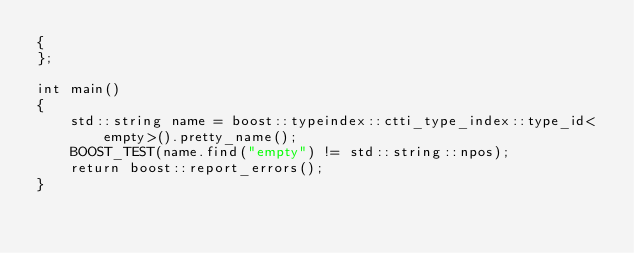<code> <loc_0><loc_0><loc_500><loc_500><_C++_>{
};

int main()
{
    std::string name = boost::typeindex::ctti_type_index::type_id<empty>().pretty_name();
    BOOST_TEST(name.find("empty") != std::string::npos);
    return boost::report_errors();
}

</code> 